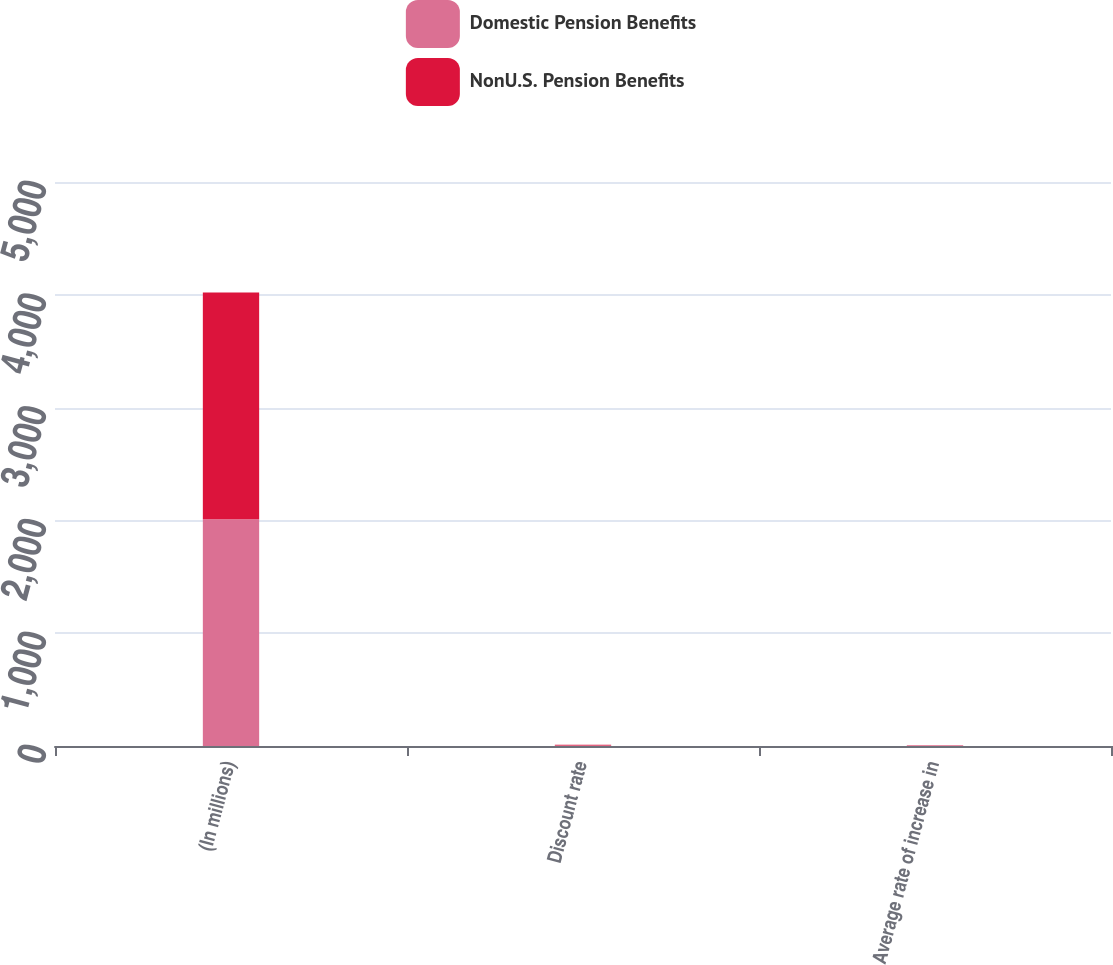Convert chart to OTSL. <chart><loc_0><loc_0><loc_500><loc_500><stacked_bar_chart><ecel><fcel>(In millions)<fcel>Discount rate<fcel>Average rate of increase in<nl><fcel>Domestic Pension Benefits<fcel>2010<fcel>5.25<fcel>4<nl><fcel>NonU.S. Pension Benefits<fcel>2010<fcel>4.77<fcel>3.34<nl></chart> 